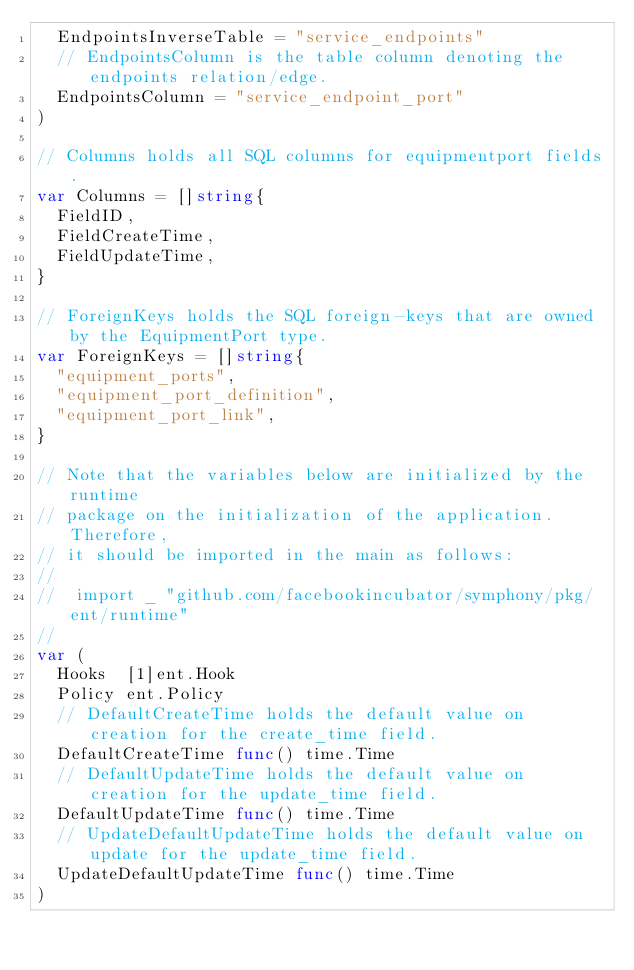Convert code to text. <code><loc_0><loc_0><loc_500><loc_500><_Go_>	EndpointsInverseTable = "service_endpoints"
	// EndpointsColumn is the table column denoting the endpoints relation/edge.
	EndpointsColumn = "service_endpoint_port"
)

// Columns holds all SQL columns for equipmentport fields.
var Columns = []string{
	FieldID,
	FieldCreateTime,
	FieldUpdateTime,
}

// ForeignKeys holds the SQL foreign-keys that are owned by the EquipmentPort type.
var ForeignKeys = []string{
	"equipment_ports",
	"equipment_port_definition",
	"equipment_port_link",
}

// Note that the variables below are initialized by the runtime
// package on the initialization of the application. Therefore,
// it should be imported in the main as follows:
//
//	import _ "github.com/facebookincubator/symphony/pkg/ent/runtime"
//
var (
	Hooks  [1]ent.Hook
	Policy ent.Policy
	// DefaultCreateTime holds the default value on creation for the create_time field.
	DefaultCreateTime func() time.Time
	// DefaultUpdateTime holds the default value on creation for the update_time field.
	DefaultUpdateTime func() time.Time
	// UpdateDefaultUpdateTime holds the default value on update for the update_time field.
	UpdateDefaultUpdateTime func() time.Time
)
</code> 